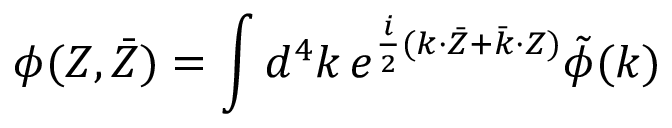Convert formula to latex. <formula><loc_0><loc_0><loc_500><loc_500>\phi ( Z , \bar { Z } ) = { \int { d ^ { 4 } k } } \, e ^ { \frac { i } { 2 } ( k { \cdot } \bar { Z } + \bar { k } { \cdot } Z ) } \tilde { \phi } ( k )</formula> 